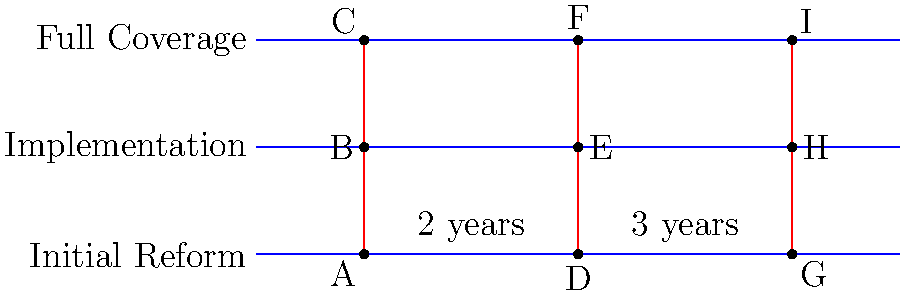In the diagram above, parallel lines represent different stages of healthcare reform implementation: Initial Reform, Implementation, and Full Coverage. Transversals represent milestones in the reform process. If the time between points A and D is 2 years, and the time between points D and G is 3 years, how long will it take to reach Full Coverage (point C) from the Initial Reform (point A)? To solve this problem, we'll use the properties of parallel lines and transversals:

1. In a system of parallel lines cut by transversals, corresponding segments are proportional.

2. We can see that segments AB, DE, and GH are corresponding segments, as are BC, EF, and HI.

3. Let's define the time from A to B as x. Then:
   - Time from A to C = 2x (since B is halfway between A and C)
   - Time from A to D = 2 years
   - Time from D to G = 3 years

4. We can set up a proportion:
   $$\frac{AB}{AD} = \frac{x}{2} = \frac{DE}{DG} = \frac{2}{3}$$

5. Solving for x:
   $$x = 2 \cdot \frac{2}{3} = \frac{4}{3}$$ years

6. Since the time from A to C is 2x:
   Time from A to C = $2 \cdot \frac{4}{3} = \frac{8}{3}$ years

Therefore, it will take $\frac{8}{3}$ years (or 2 years and 8 months) to reach Full Coverage from Initial Reform.
Answer: $\frac{8}{3}$ years 